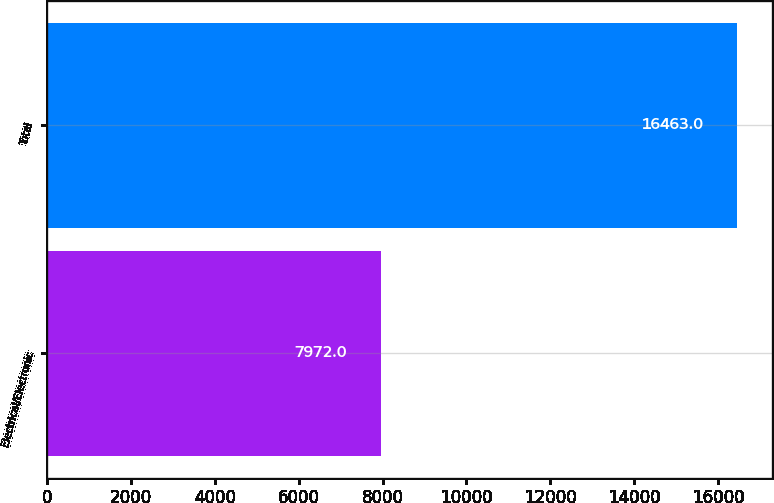<chart> <loc_0><loc_0><loc_500><loc_500><bar_chart><fcel>Electrical/Electronic<fcel>Total<nl><fcel>7972<fcel>16463<nl></chart> 